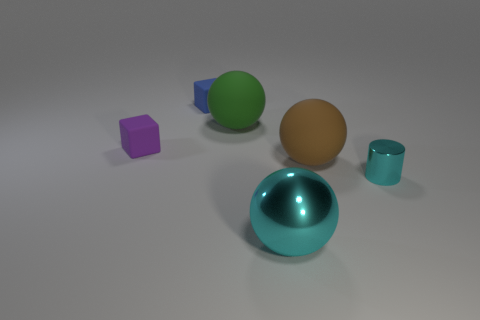Add 1 small cyan objects. How many objects exist? 7 Subtract all cylinders. How many objects are left? 5 Add 2 small shiny cylinders. How many small shiny cylinders are left? 3 Add 3 small brown matte cylinders. How many small brown matte cylinders exist? 3 Subtract 0 gray spheres. How many objects are left? 6 Subtract all tiny green shiny objects. Subtract all balls. How many objects are left? 3 